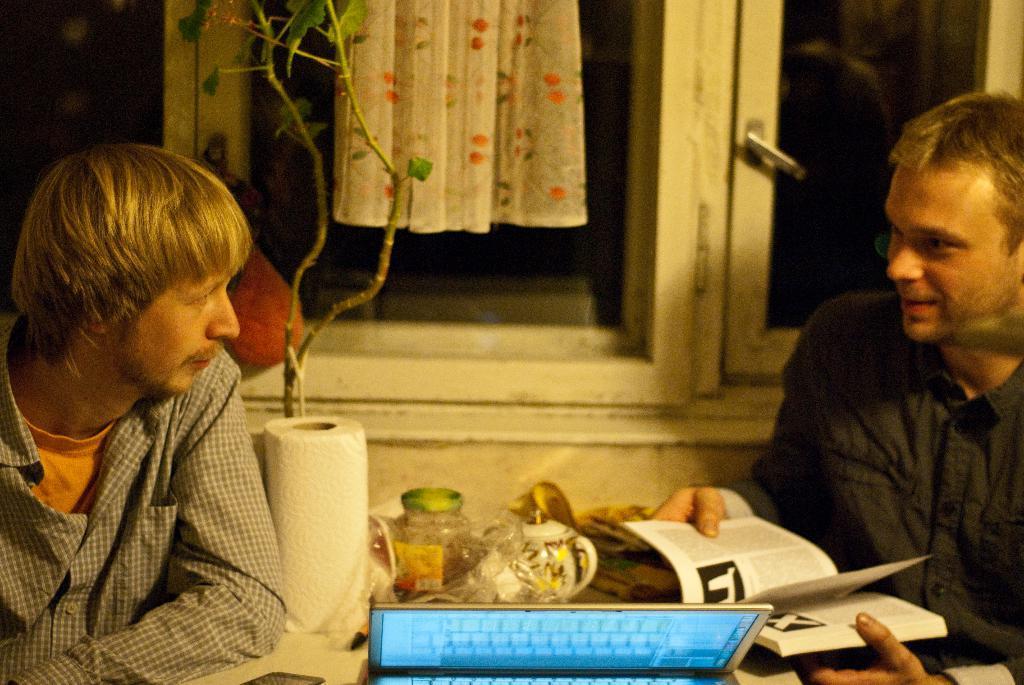How would you summarize this image in a sentence or two? In this picture I can see couple of men sitting and I can see a plant, a book, a laptop, a paper roll and few items on the table. I can see a cloth and a window in the background. 